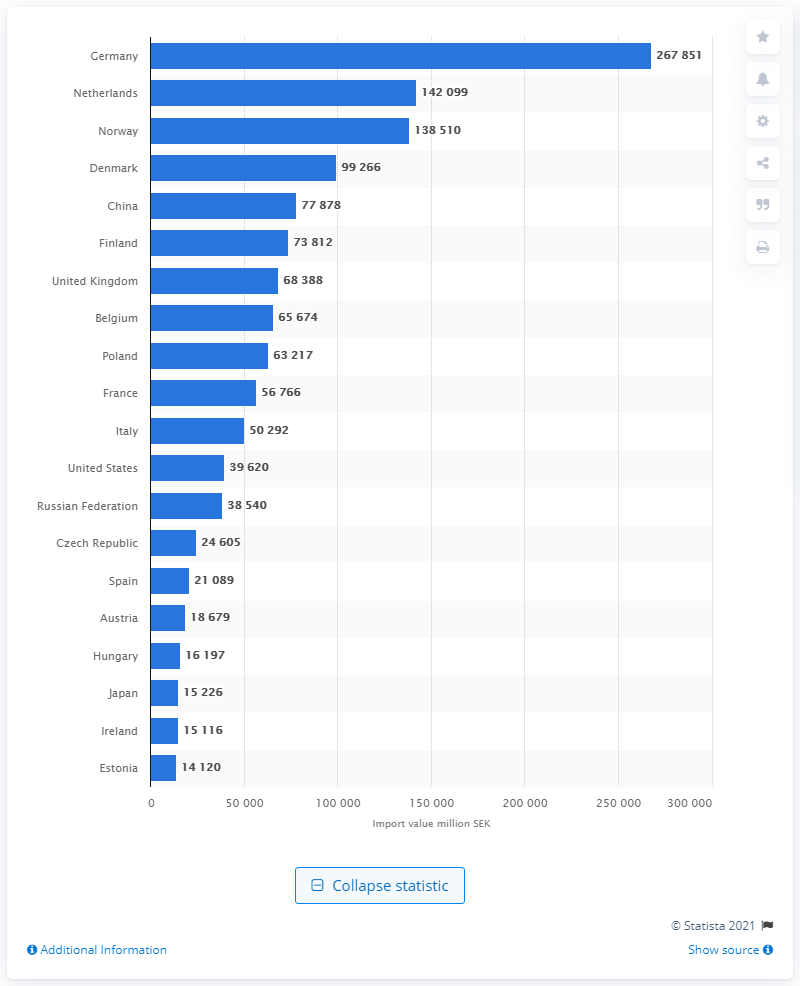Outline some significant characteristics in this image. In 2019, Norway was Sweden's largest trading partner. In 2019, the value of goods imported from the Netherlands was 142,099. In 2019, Sweden's largest trading partner was Germany. In 2019, a total of 267,851 Swedish kronor was imported into Sweden. 